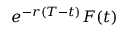Convert formula to latex. <formula><loc_0><loc_0><loc_500><loc_500>e ^ { - r ( T - t ) } F ( t )</formula> 